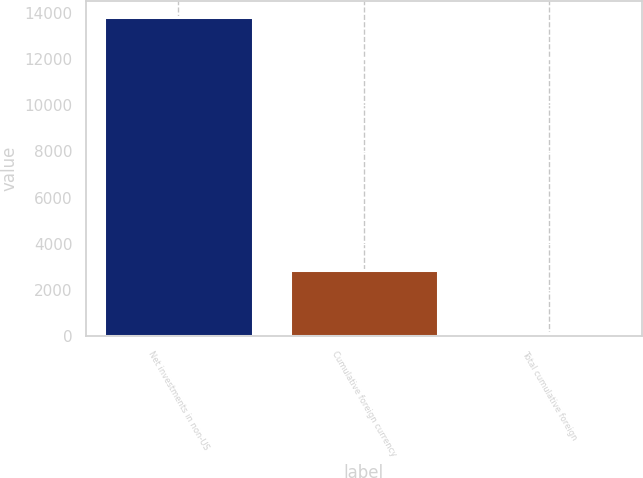Convert chart to OTSL. <chart><loc_0><loc_0><loc_500><loc_500><bar_chart><fcel>Net investments in non-US<fcel>Cumulative foreign currency<fcel>Total cumulative foreign<nl><fcel>13811<fcel>2860.6<fcel>123<nl></chart> 